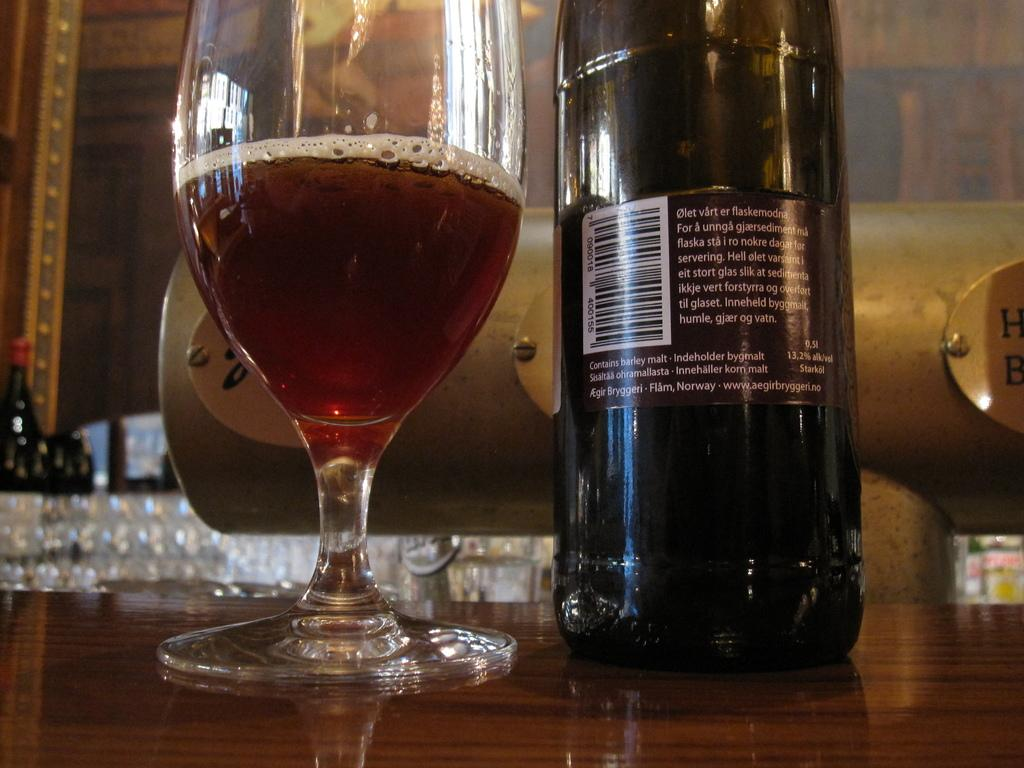Provide a one-sentence caption for the provided image. The back label of a bottle of wine from Norway. 